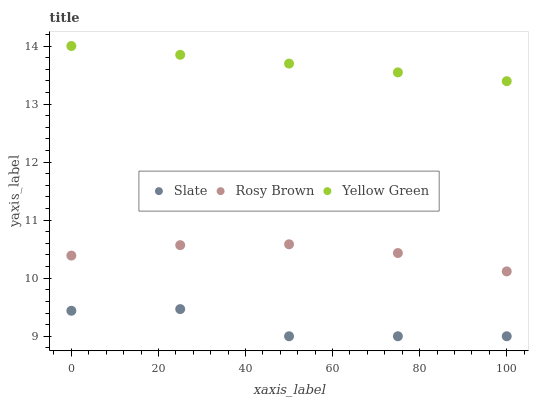Does Slate have the minimum area under the curve?
Answer yes or no. Yes. Does Yellow Green have the maximum area under the curve?
Answer yes or no. Yes. Does Rosy Brown have the minimum area under the curve?
Answer yes or no. No. Does Rosy Brown have the maximum area under the curve?
Answer yes or no. No. Is Yellow Green the smoothest?
Answer yes or no. Yes. Is Slate the roughest?
Answer yes or no. Yes. Is Rosy Brown the smoothest?
Answer yes or no. No. Is Rosy Brown the roughest?
Answer yes or no. No. Does Slate have the lowest value?
Answer yes or no. Yes. Does Rosy Brown have the lowest value?
Answer yes or no. No. Does Yellow Green have the highest value?
Answer yes or no. Yes. Does Rosy Brown have the highest value?
Answer yes or no. No. Is Rosy Brown less than Yellow Green?
Answer yes or no. Yes. Is Yellow Green greater than Rosy Brown?
Answer yes or no. Yes. Does Rosy Brown intersect Yellow Green?
Answer yes or no. No. 